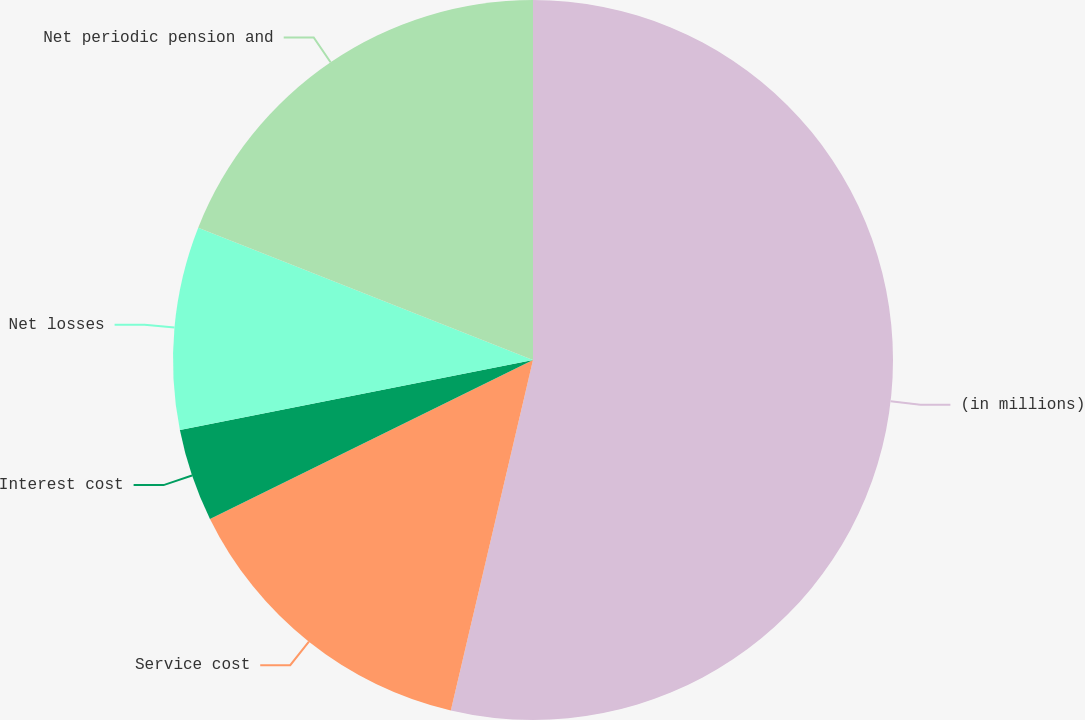Convert chart to OTSL. <chart><loc_0><loc_0><loc_500><loc_500><pie_chart><fcel>(in millions)<fcel>Service cost<fcel>Interest cost<fcel>Net losses<fcel>Net periodic pension and<nl><fcel>53.67%<fcel>14.06%<fcel>4.16%<fcel>9.11%<fcel>19.01%<nl></chart> 